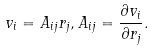<formula> <loc_0><loc_0><loc_500><loc_500>v _ { i } = A _ { i j } r _ { j } , A _ { i j } = \frac { \partial v _ { i } } { \partial r _ { j } } .</formula> 